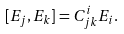Convert formula to latex. <formula><loc_0><loc_0><loc_500><loc_500>[ E _ { j } , E _ { k } ] = C ^ { i } _ { j k } E _ { i } .</formula> 